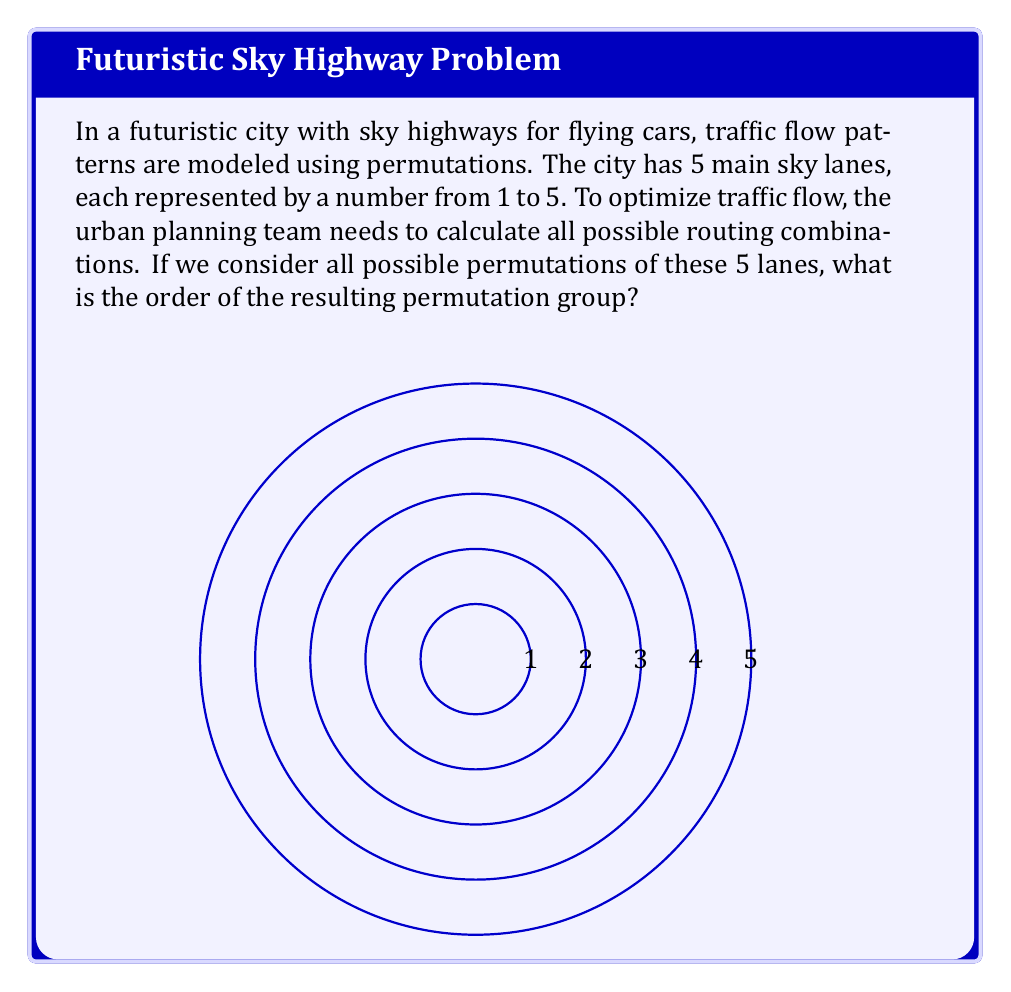Can you answer this question? To solve this problem, we need to understand the concept of permutation groups and how to calculate their order.

1) A permutation group on a set of n elements consists of all possible rearrangements (permutations) of these elements.

2) The order of a permutation group is the total number of distinct permutations possible.

3) For a set of n distinct elements, the number of permutations is given by n! (n factorial).

4) In this case, we have 5 sky lanes, so n = 5.

5) Therefore, the order of the permutation group is:

   $$5! = 5 \times 4 \times 3 \times 2 \times 1 = 120$$

This means there are 120 possible ways to rearrange the 5 sky lanes, representing all possible routing combinations for optimizing traffic flow.
Answer: 120 